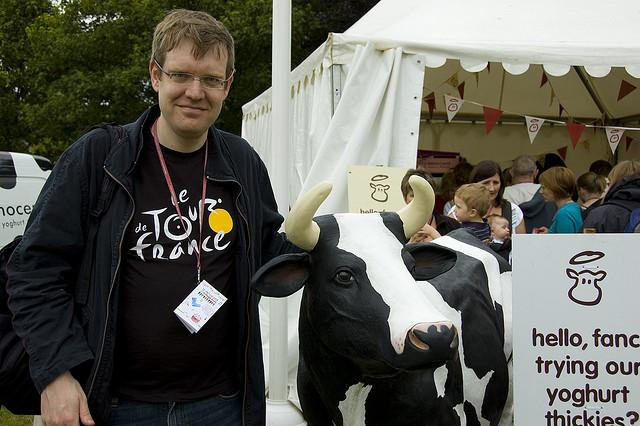What type of industry is being represented? Please explain your reasoning. dairy. The industry is the dairy one. 